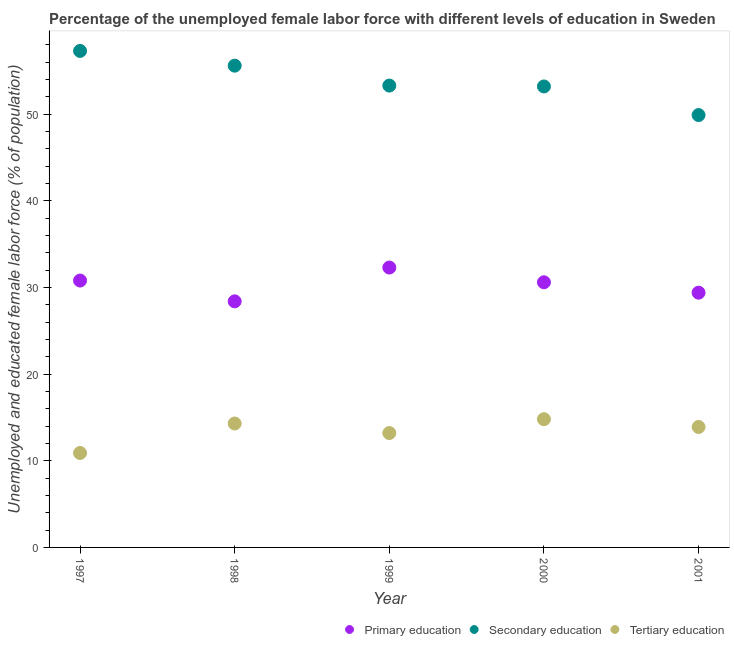What is the percentage of female labor force who received tertiary education in 1999?
Offer a terse response. 13.2. Across all years, what is the maximum percentage of female labor force who received primary education?
Your answer should be very brief. 32.3. Across all years, what is the minimum percentage of female labor force who received secondary education?
Offer a terse response. 49.9. What is the total percentage of female labor force who received secondary education in the graph?
Give a very brief answer. 269.3. What is the difference between the percentage of female labor force who received primary education in 1998 and that in 1999?
Provide a succinct answer. -3.9. What is the difference between the percentage of female labor force who received tertiary education in 1999 and the percentage of female labor force who received secondary education in 2000?
Offer a very short reply. -40. What is the average percentage of female labor force who received primary education per year?
Give a very brief answer. 30.3. In the year 1997, what is the difference between the percentage of female labor force who received tertiary education and percentage of female labor force who received secondary education?
Make the answer very short. -46.4. What is the ratio of the percentage of female labor force who received primary education in 1998 to that in 1999?
Give a very brief answer. 0.88. What is the difference between the highest and the second highest percentage of female labor force who received primary education?
Provide a short and direct response. 1.5. What is the difference between the highest and the lowest percentage of female labor force who received secondary education?
Give a very brief answer. 7.4. Is the sum of the percentage of female labor force who received secondary education in 1997 and 2000 greater than the maximum percentage of female labor force who received primary education across all years?
Keep it short and to the point. Yes. Is it the case that in every year, the sum of the percentage of female labor force who received primary education and percentage of female labor force who received secondary education is greater than the percentage of female labor force who received tertiary education?
Provide a succinct answer. Yes. How many dotlines are there?
Offer a very short reply. 3. What is the difference between two consecutive major ticks on the Y-axis?
Your answer should be compact. 10. Does the graph contain grids?
Your response must be concise. No. Where does the legend appear in the graph?
Make the answer very short. Bottom right. How many legend labels are there?
Your answer should be compact. 3. What is the title of the graph?
Keep it short and to the point. Percentage of the unemployed female labor force with different levels of education in Sweden. What is the label or title of the X-axis?
Provide a succinct answer. Year. What is the label or title of the Y-axis?
Give a very brief answer. Unemployed and educated female labor force (% of population). What is the Unemployed and educated female labor force (% of population) of Primary education in 1997?
Your answer should be compact. 30.8. What is the Unemployed and educated female labor force (% of population) in Secondary education in 1997?
Offer a very short reply. 57.3. What is the Unemployed and educated female labor force (% of population) in Tertiary education in 1997?
Ensure brevity in your answer.  10.9. What is the Unemployed and educated female labor force (% of population) in Primary education in 1998?
Give a very brief answer. 28.4. What is the Unemployed and educated female labor force (% of population) of Secondary education in 1998?
Your answer should be very brief. 55.6. What is the Unemployed and educated female labor force (% of population) in Tertiary education in 1998?
Your response must be concise. 14.3. What is the Unemployed and educated female labor force (% of population) in Primary education in 1999?
Make the answer very short. 32.3. What is the Unemployed and educated female labor force (% of population) in Secondary education in 1999?
Your answer should be very brief. 53.3. What is the Unemployed and educated female labor force (% of population) of Tertiary education in 1999?
Provide a succinct answer. 13.2. What is the Unemployed and educated female labor force (% of population) of Primary education in 2000?
Provide a short and direct response. 30.6. What is the Unemployed and educated female labor force (% of population) of Secondary education in 2000?
Your response must be concise. 53.2. What is the Unemployed and educated female labor force (% of population) of Tertiary education in 2000?
Keep it short and to the point. 14.8. What is the Unemployed and educated female labor force (% of population) in Primary education in 2001?
Offer a very short reply. 29.4. What is the Unemployed and educated female labor force (% of population) of Secondary education in 2001?
Offer a terse response. 49.9. What is the Unemployed and educated female labor force (% of population) in Tertiary education in 2001?
Your answer should be very brief. 13.9. Across all years, what is the maximum Unemployed and educated female labor force (% of population) in Primary education?
Your response must be concise. 32.3. Across all years, what is the maximum Unemployed and educated female labor force (% of population) in Secondary education?
Offer a terse response. 57.3. Across all years, what is the maximum Unemployed and educated female labor force (% of population) in Tertiary education?
Offer a very short reply. 14.8. Across all years, what is the minimum Unemployed and educated female labor force (% of population) in Primary education?
Your response must be concise. 28.4. Across all years, what is the minimum Unemployed and educated female labor force (% of population) of Secondary education?
Your answer should be very brief. 49.9. Across all years, what is the minimum Unemployed and educated female labor force (% of population) in Tertiary education?
Ensure brevity in your answer.  10.9. What is the total Unemployed and educated female labor force (% of population) in Primary education in the graph?
Your answer should be compact. 151.5. What is the total Unemployed and educated female labor force (% of population) of Secondary education in the graph?
Give a very brief answer. 269.3. What is the total Unemployed and educated female labor force (% of population) in Tertiary education in the graph?
Provide a succinct answer. 67.1. What is the difference between the Unemployed and educated female labor force (% of population) of Tertiary education in 1997 and that in 1998?
Offer a terse response. -3.4. What is the difference between the Unemployed and educated female labor force (% of population) in Primary education in 1997 and that in 1999?
Your answer should be compact. -1.5. What is the difference between the Unemployed and educated female labor force (% of population) in Secondary education in 1997 and that in 1999?
Your response must be concise. 4. What is the difference between the Unemployed and educated female labor force (% of population) in Primary education in 1997 and that in 2000?
Your answer should be compact. 0.2. What is the difference between the Unemployed and educated female labor force (% of population) in Secondary education in 1997 and that in 2000?
Ensure brevity in your answer.  4.1. What is the difference between the Unemployed and educated female labor force (% of population) in Tertiary education in 1997 and that in 2000?
Ensure brevity in your answer.  -3.9. What is the difference between the Unemployed and educated female labor force (% of population) in Primary education in 1997 and that in 2001?
Provide a short and direct response. 1.4. What is the difference between the Unemployed and educated female labor force (% of population) in Tertiary education in 1997 and that in 2001?
Offer a very short reply. -3. What is the difference between the Unemployed and educated female labor force (% of population) of Primary education in 1998 and that in 2000?
Offer a terse response. -2.2. What is the difference between the Unemployed and educated female labor force (% of population) of Secondary education in 1998 and that in 2000?
Offer a terse response. 2.4. What is the difference between the Unemployed and educated female labor force (% of population) of Primary education in 1998 and that in 2001?
Offer a terse response. -1. What is the difference between the Unemployed and educated female labor force (% of population) of Tertiary education in 1998 and that in 2001?
Make the answer very short. 0.4. What is the difference between the Unemployed and educated female labor force (% of population) in Primary education in 1999 and that in 2000?
Your answer should be compact. 1.7. What is the difference between the Unemployed and educated female labor force (% of population) in Tertiary education in 1999 and that in 2000?
Your answer should be compact. -1.6. What is the difference between the Unemployed and educated female labor force (% of population) of Tertiary education in 1999 and that in 2001?
Give a very brief answer. -0.7. What is the difference between the Unemployed and educated female labor force (% of population) in Tertiary education in 2000 and that in 2001?
Provide a succinct answer. 0.9. What is the difference between the Unemployed and educated female labor force (% of population) of Primary education in 1997 and the Unemployed and educated female labor force (% of population) of Secondary education in 1998?
Your answer should be very brief. -24.8. What is the difference between the Unemployed and educated female labor force (% of population) in Secondary education in 1997 and the Unemployed and educated female labor force (% of population) in Tertiary education in 1998?
Provide a short and direct response. 43. What is the difference between the Unemployed and educated female labor force (% of population) in Primary education in 1997 and the Unemployed and educated female labor force (% of population) in Secondary education in 1999?
Offer a very short reply. -22.5. What is the difference between the Unemployed and educated female labor force (% of population) in Secondary education in 1997 and the Unemployed and educated female labor force (% of population) in Tertiary education in 1999?
Give a very brief answer. 44.1. What is the difference between the Unemployed and educated female labor force (% of population) in Primary education in 1997 and the Unemployed and educated female labor force (% of population) in Secondary education in 2000?
Your answer should be very brief. -22.4. What is the difference between the Unemployed and educated female labor force (% of population) of Primary education in 1997 and the Unemployed and educated female labor force (% of population) of Tertiary education in 2000?
Ensure brevity in your answer.  16. What is the difference between the Unemployed and educated female labor force (% of population) of Secondary education in 1997 and the Unemployed and educated female labor force (% of population) of Tertiary education in 2000?
Give a very brief answer. 42.5. What is the difference between the Unemployed and educated female labor force (% of population) in Primary education in 1997 and the Unemployed and educated female labor force (% of population) in Secondary education in 2001?
Your answer should be compact. -19.1. What is the difference between the Unemployed and educated female labor force (% of population) in Secondary education in 1997 and the Unemployed and educated female labor force (% of population) in Tertiary education in 2001?
Provide a short and direct response. 43.4. What is the difference between the Unemployed and educated female labor force (% of population) in Primary education in 1998 and the Unemployed and educated female labor force (% of population) in Secondary education in 1999?
Provide a succinct answer. -24.9. What is the difference between the Unemployed and educated female labor force (% of population) in Primary education in 1998 and the Unemployed and educated female labor force (% of population) in Tertiary education in 1999?
Provide a succinct answer. 15.2. What is the difference between the Unemployed and educated female labor force (% of population) in Secondary education in 1998 and the Unemployed and educated female labor force (% of population) in Tertiary education in 1999?
Give a very brief answer. 42.4. What is the difference between the Unemployed and educated female labor force (% of population) in Primary education in 1998 and the Unemployed and educated female labor force (% of population) in Secondary education in 2000?
Offer a terse response. -24.8. What is the difference between the Unemployed and educated female labor force (% of population) in Secondary education in 1998 and the Unemployed and educated female labor force (% of population) in Tertiary education in 2000?
Provide a short and direct response. 40.8. What is the difference between the Unemployed and educated female labor force (% of population) in Primary education in 1998 and the Unemployed and educated female labor force (% of population) in Secondary education in 2001?
Provide a succinct answer. -21.5. What is the difference between the Unemployed and educated female labor force (% of population) of Primary education in 1998 and the Unemployed and educated female labor force (% of population) of Tertiary education in 2001?
Your answer should be compact. 14.5. What is the difference between the Unemployed and educated female labor force (% of population) of Secondary education in 1998 and the Unemployed and educated female labor force (% of population) of Tertiary education in 2001?
Offer a very short reply. 41.7. What is the difference between the Unemployed and educated female labor force (% of population) of Primary education in 1999 and the Unemployed and educated female labor force (% of population) of Secondary education in 2000?
Your answer should be very brief. -20.9. What is the difference between the Unemployed and educated female labor force (% of population) of Primary education in 1999 and the Unemployed and educated female labor force (% of population) of Tertiary education in 2000?
Make the answer very short. 17.5. What is the difference between the Unemployed and educated female labor force (% of population) of Secondary education in 1999 and the Unemployed and educated female labor force (% of population) of Tertiary education in 2000?
Provide a succinct answer. 38.5. What is the difference between the Unemployed and educated female labor force (% of population) of Primary education in 1999 and the Unemployed and educated female labor force (% of population) of Secondary education in 2001?
Your answer should be very brief. -17.6. What is the difference between the Unemployed and educated female labor force (% of population) in Primary education in 1999 and the Unemployed and educated female labor force (% of population) in Tertiary education in 2001?
Provide a succinct answer. 18.4. What is the difference between the Unemployed and educated female labor force (% of population) of Secondary education in 1999 and the Unemployed and educated female labor force (% of population) of Tertiary education in 2001?
Provide a short and direct response. 39.4. What is the difference between the Unemployed and educated female labor force (% of population) in Primary education in 2000 and the Unemployed and educated female labor force (% of population) in Secondary education in 2001?
Give a very brief answer. -19.3. What is the difference between the Unemployed and educated female labor force (% of population) of Primary education in 2000 and the Unemployed and educated female labor force (% of population) of Tertiary education in 2001?
Ensure brevity in your answer.  16.7. What is the difference between the Unemployed and educated female labor force (% of population) of Secondary education in 2000 and the Unemployed and educated female labor force (% of population) of Tertiary education in 2001?
Keep it short and to the point. 39.3. What is the average Unemployed and educated female labor force (% of population) of Primary education per year?
Give a very brief answer. 30.3. What is the average Unemployed and educated female labor force (% of population) of Secondary education per year?
Offer a very short reply. 53.86. What is the average Unemployed and educated female labor force (% of population) of Tertiary education per year?
Provide a short and direct response. 13.42. In the year 1997, what is the difference between the Unemployed and educated female labor force (% of population) of Primary education and Unemployed and educated female labor force (% of population) of Secondary education?
Your response must be concise. -26.5. In the year 1997, what is the difference between the Unemployed and educated female labor force (% of population) in Primary education and Unemployed and educated female labor force (% of population) in Tertiary education?
Your answer should be very brief. 19.9. In the year 1997, what is the difference between the Unemployed and educated female labor force (% of population) of Secondary education and Unemployed and educated female labor force (% of population) of Tertiary education?
Make the answer very short. 46.4. In the year 1998, what is the difference between the Unemployed and educated female labor force (% of population) in Primary education and Unemployed and educated female labor force (% of population) in Secondary education?
Your answer should be very brief. -27.2. In the year 1998, what is the difference between the Unemployed and educated female labor force (% of population) of Secondary education and Unemployed and educated female labor force (% of population) of Tertiary education?
Offer a terse response. 41.3. In the year 1999, what is the difference between the Unemployed and educated female labor force (% of population) of Primary education and Unemployed and educated female labor force (% of population) of Secondary education?
Give a very brief answer. -21. In the year 1999, what is the difference between the Unemployed and educated female labor force (% of population) of Primary education and Unemployed and educated female labor force (% of population) of Tertiary education?
Make the answer very short. 19.1. In the year 1999, what is the difference between the Unemployed and educated female labor force (% of population) in Secondary education and Unemployed and educated female labor force (% of population) in Tertiary education?
Your answer should be compact. 40.1. In the year 2000, what is the difference between the Unemployed and educated female labor force (% of population) of Primary education and Unemployed and educated female labor force (% of population) of Secondary education?
Provide a succinct answer. -22.6. In the year 2000, what is the difference between the Unemployed and educated female labor force (% of population) in Secondary education and Unemployed and educated female labor force (% of population) in Tertiary education?
Your answer should be very brief. 38.4. In the year 2001, what is the difference between the Unemployed and educated female labor force (% of population) in Primary education and Unemployed and educated female labor force (% of population) in Secondary education?
Give a very brief answer. -20.5. In the year 2001, what is the difference between the Unemployed and educated female labor force (% of population) in Primary education and Unemployed and educated female labor force (% of population) in Tertiary education?
Your response must be concise. 15.5. What is the ratio of the Unemployed and educated female labor force (% of population) in Primary education in 1997 to that in 1998?
Offer a terse response. 1.08. What is the ratio of the Unemployed and educated female labor force (% of population) in Secondary education in 1997 to that in 1998?
Provide a succinct answer. 1.03. What is the ratio of the Unemployed and educated female labor force (% of population) in Tertiary education in 1997 to that in 1998?
Provide a succinct answer. 0.76. What is the ratio of the Unemployed and educated female labor force (% of population) in Primary education in 1997 to that in 1999?
Your response must be concise. 0.95. What is the ratio of the Unemployed and educated female labor force (% of population) of Secondary education in 1997 to that in 1999?
Offer a very short reply. 1.07. What is the ratio of the Unemployed and educated female labor force (% of population) of Tertiary education in 1997 to that in 1999?
Offer a very short reply. 0.83. What is the ratio of the Unemployed and educated female labor force (% of population) of Secondary education in 1997 to that in 2000?
Keep it short and to the point. 1.08. What is the ratio of the Unemployed and educated female labor force (% of population) of Tertiary education in 1997 to that in 2000?
Make the answer very short. 0.74. What is the ratio of the Unemployed and educated female labor force (% of population) of Primary education in 1997 to that in 2001?
Offer a terse response. 1.05. What is the ratio of the Unemployed and educated female labor force (% of population) in Secondary education in 1997 to that in 2001?
Your response must be concise. 1.15. What is the ratio of the Unemployed and educated female labor force (% of population) of Tertiary education in 1997 to that in 2001?
Provide a succinct answer. 0.78. What is the ratio of the Unemployed and educated female labor force (% of population) of Primary education in 1998 to that in 1999?
Ensure brevity in your answer.  0.88. What is the ratio of the Unemployed and educated female labor force (% of population) of Secondary education in 1998 to that in 1999?
Provide a short and direct response. 1.04. What is the ratio of the Unemployed and educated female labor force (% of population) in Tertiary education in 1998 to that in 1999?
Make the answer very short. 1.08. What is the ratio of the Unemployed and educated female labor force (% of population) in Primary education in 1998 to that in 2000?
Ensure brevity in your answer.  0.93. What is the ratio of the Unemployed and educated female labor force (% of population) of Secondary education in 1998 to that in 2000?
Offer a very short reply. 1.05. What is the ratio of the Unemployed and educated female labor force (% of population) of Tertiary education in 1998 to that in 2000?
Ensure brevity in your answer.  0.97. What is the ratio of the Unemployed and educated female labor force (% of population) of Primary education in 1998 to that in 2001?
Provide a succinct answer. 0.97. What is the ratio of the Unemployed and educated female labor force (% of population) in Secondary education in 1998 to that in 2001?
Provide a succinct answer. 1.11. What is the ratio of the Unemployed and educated female labor force (% of population) in Tertiary education in 1998 to that in 2001?
Give a very brief answer. 1.03. What is the ratio of the Unemployed and educated female labor force (% of population) in Primary education in 1999 to that in 2000?
Offer a very short reply. 1.06. What is the ratio of the Unemployed and educated female labor force (% of population) of Tertiary education in 1999 to that in 2000?
Your answer should be compact. 0.89. What is the ratio of the Unemployed and educated female labor force (% of population) in Primary education in 1999 to that in 2001?
Your answer should be very brief. 1.1. What is the ratio of the Unemployed and educated female labor force (% of population) of Secondary education in 1999 to that in 2001?
Give a very brief answer. 1.07. What is the ratio of the Unemployed and educated female labor force (% of population) of Tertiary education in 1999 to that in 2001?
Your answer should be very brief. 0.95. What is the ratio of the Unemployed and educated female labor force (% of population) in Primary education in 2000 to that in 2001?
Offer a terse response. 1.04. What is the ratio of the Unemployed and educated female labor force (% of population) in Secondary education in 2000 to that in 2001?
Keep it short and to the point. 1.07. What is the ratio of the Unemployed and educated female labor force (% of population) in Tertiary education in 2000 to that in 2001?
Give a very brief answer. 1.06. What is the difference between the highest and the second highest Unemployed and educated female labor force (% of population) of Primary education?
Your answer should be compact. 1.5. What is the difference between the highest and the lowest Unemployed and educated female labor force (% of population) of Primary education?
Ensure brevity in your answer.  3.9. 